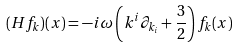<formula> <loc_0><loc_0><loc_500><loc_500>( H f _ { k } ) ( x ) = - i \omega \left ( k ^ { i } \partial _ { k _ { i } } + { \frac { 3 } { 2 } } \right ) f _ { k } ( x )</formula> 